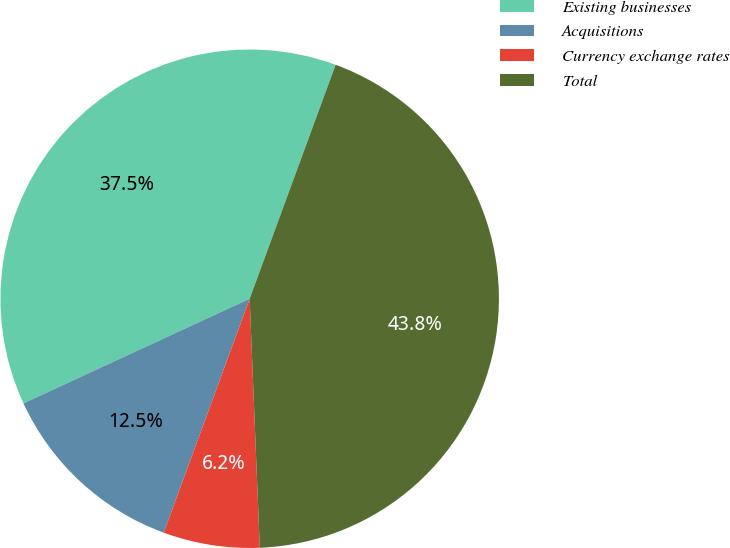Convert chart. <chart><loc_0><loc_0><loc_500><loc_500><pie_chart><fcel>Existing businesses<fcel>Acquisitions<fcel>Currency exchange rates<fcel>Total<nl><fcel>37.5%<fcel>12.5%<fcel>6.25%<fcel>43.75%<nl></chart> 